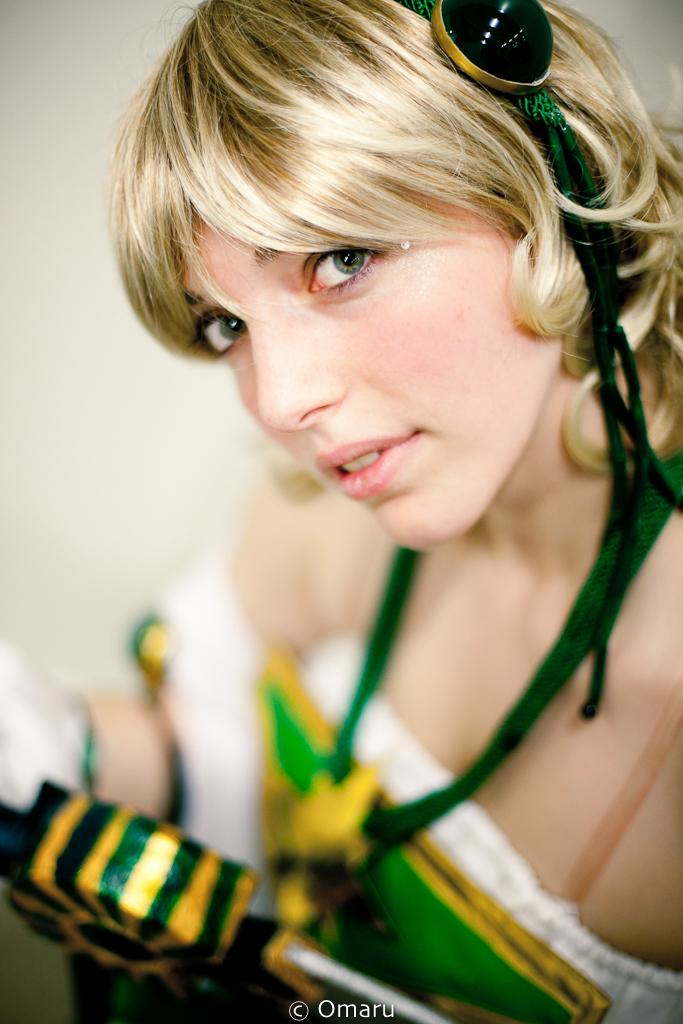Who is the main subject in the image? There is a lady in the image. What is the lady wearing? The lady is wearing a green dress. What can be seen in the background of the image? There is a wall in the background of the image. Is the lady reading a book in the image? There is no book or indication of reading in the image. 